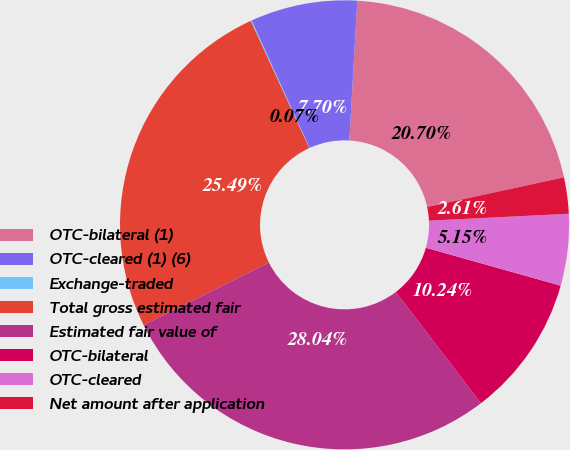<chart> <loc_0><loc_0><loc_500><loc_500><pie_chart><fcel>OTC-bilateral (1)<fcel>OTC-cleared (1) (6)<fcel>Exchange-traded<fcel>Total gross estimated fair<fcel>Estimated fair value of<fcel>OTC-bilateral<fcel>OTC-cleared<fcel>Net amount after application<nl><fcel>20.7%<fcel>7.7%<fcel>0.07%<fcel>25.49%<fcel>28.04%<fcel>10.24%<fcel>5.15%<fcel>2.61%<nl></chart> 